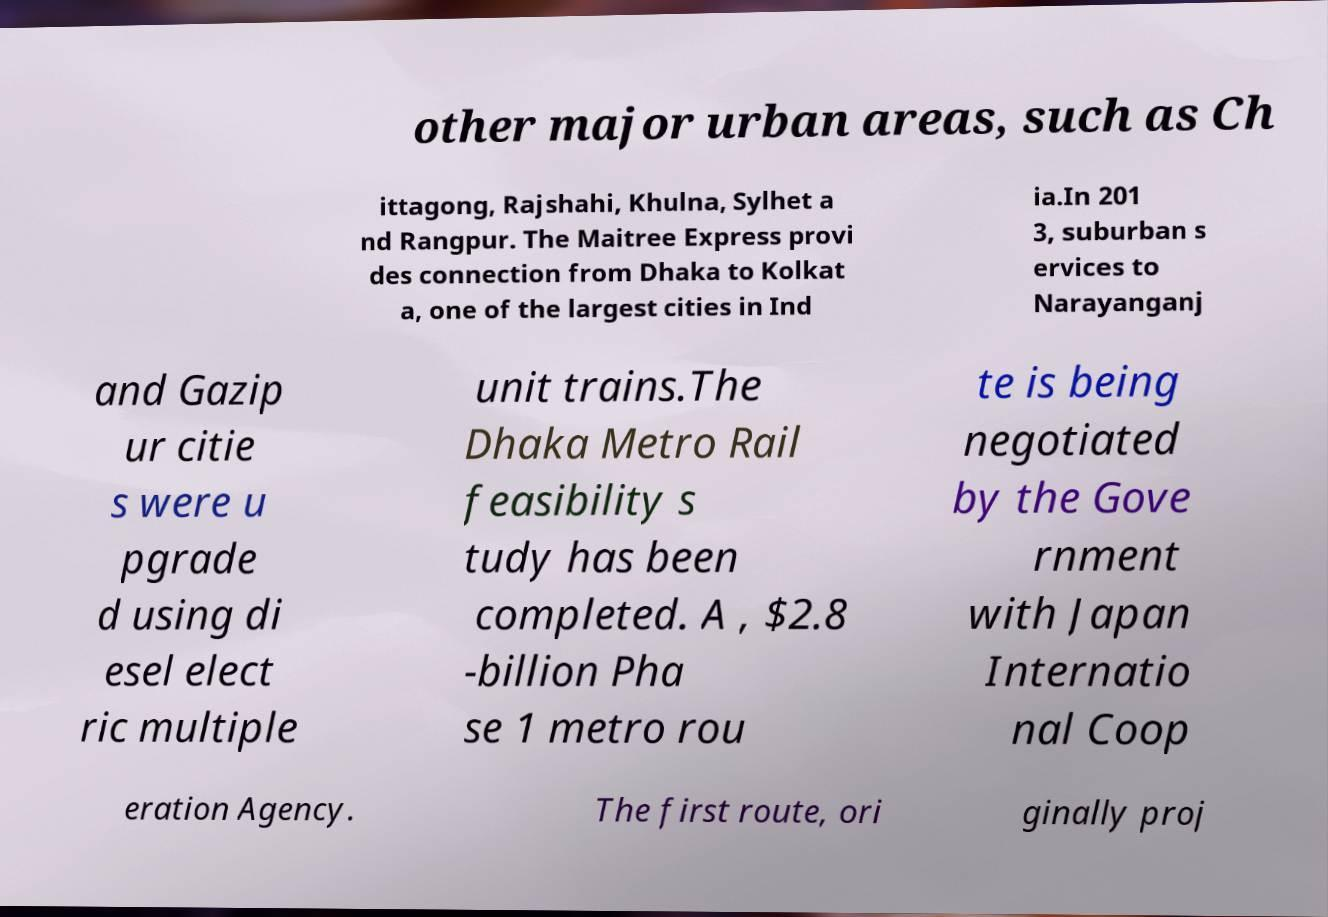For documentation purposes, I need the text within this image transcribed. Could you provide that? other major urban areas, such as Ch ittagong, Rajshahi, Khulna, Sylhet a nd Rangpur. The Maitree Express provi des connection from Dhaka to Kolkat a, one of the largest cities in Ind ia.In 201 3, suburban s ervices to Narayanganj and Gazip ur citie s were u pgrade d using di esel elect ric multiple unit trains.The Dhaka Metro Rail feasibility s tudy has been completed. A , $2.8 -billion Pha se 1 metro rou te is being negotiated by the Gove rnment with Japan Internatio nal Coop eration Agency. The first route, ori ginally proj 